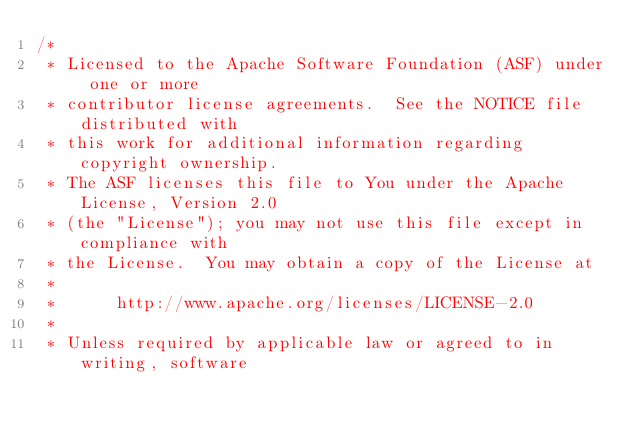<code> <loc_0><loc_0><loc_500><loc_500><_Java_>/*
 * Licensed to the Apache Software Foundation (ASF) under one or more
 * contributor license agreements.  See the NOTICE file distributed with
 * this work for additional information regarding copyright ownership.
 * The ASF licenses this file to You under the Apache License, Version 2.0
 * (the "License"); you may not use this file except in compliance with
 * the License.  You may obtain a copy of the License at
 *
 *      http://www.apache.org/licenses/LICENSE-2.0
 *
 * Unless required by applicable law or agreed to in writing, software</code> 